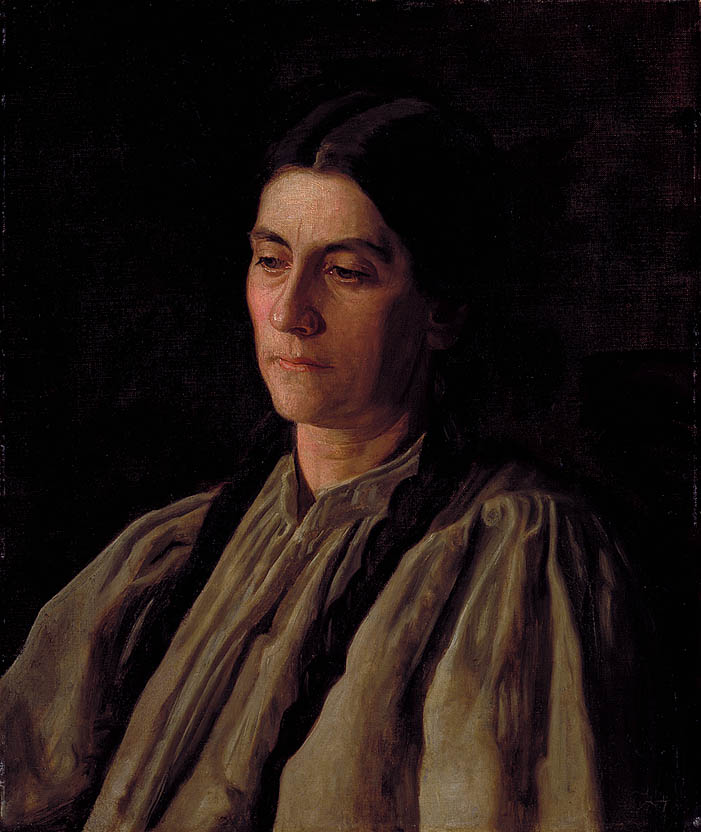Can you tell me more about the implications of her expression in this portrait? Certainly, her expression, coupled with the subdued lighting and dark background, evokes a sense of resignation or deep contemplation. It might reflect her personal challenges or broader societal issues faced during the time this portrait was painted. The somber tone suggests she could be reflecting on significant matters, potentially personal loss or societal change. Her gaze is downward, and her face does not show fleeting emotions, rather a settled, enduring sentiment that suggests a narrative of endurance and quiet strength. 